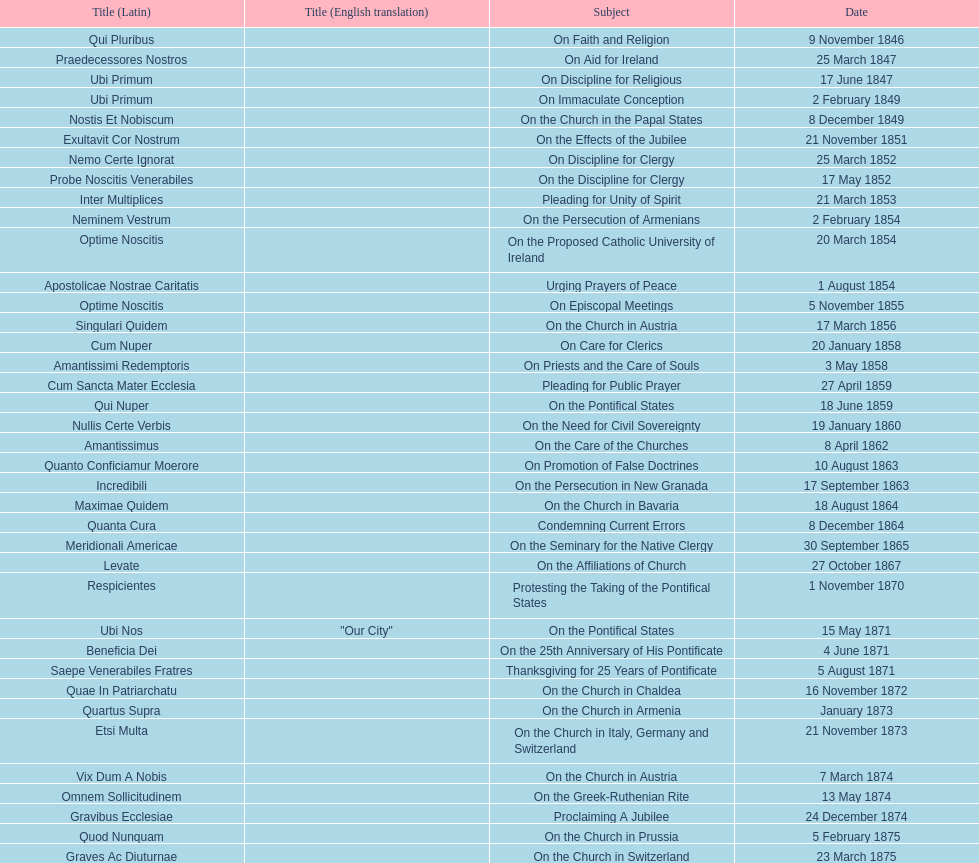In the first 10 years of his reign, how many encyclicals did pope pius ix issue? 14. 